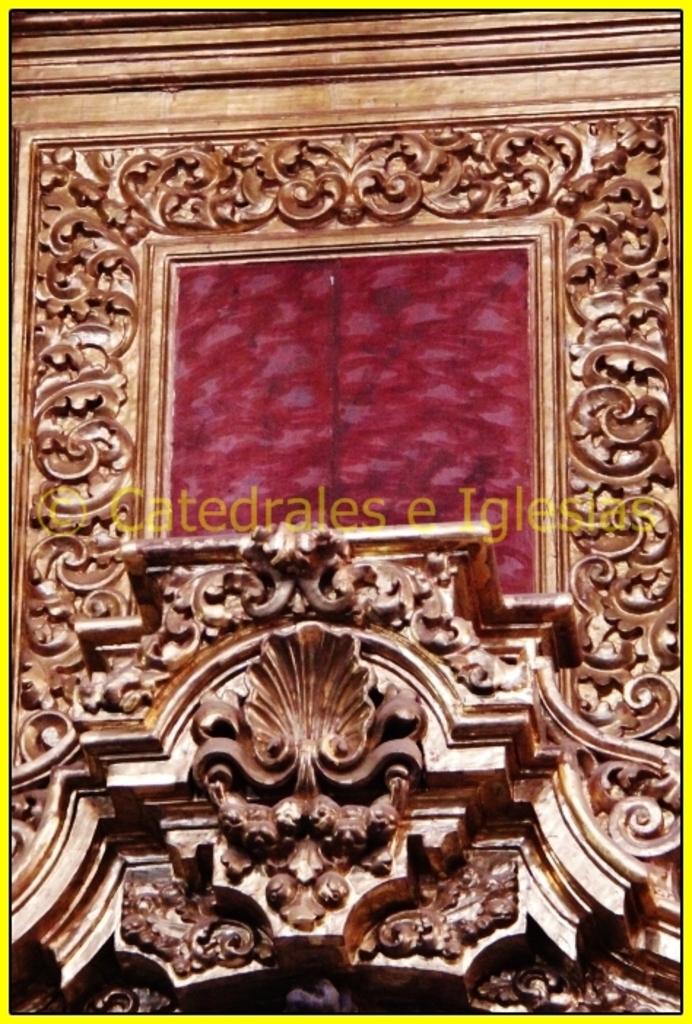Who is the copy right owner?
Make the answer very short. Catedrales e iglesias. 